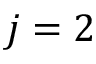<formula> <loc_0><loc_0><loc_500><loc_500>j = 2</formula> 